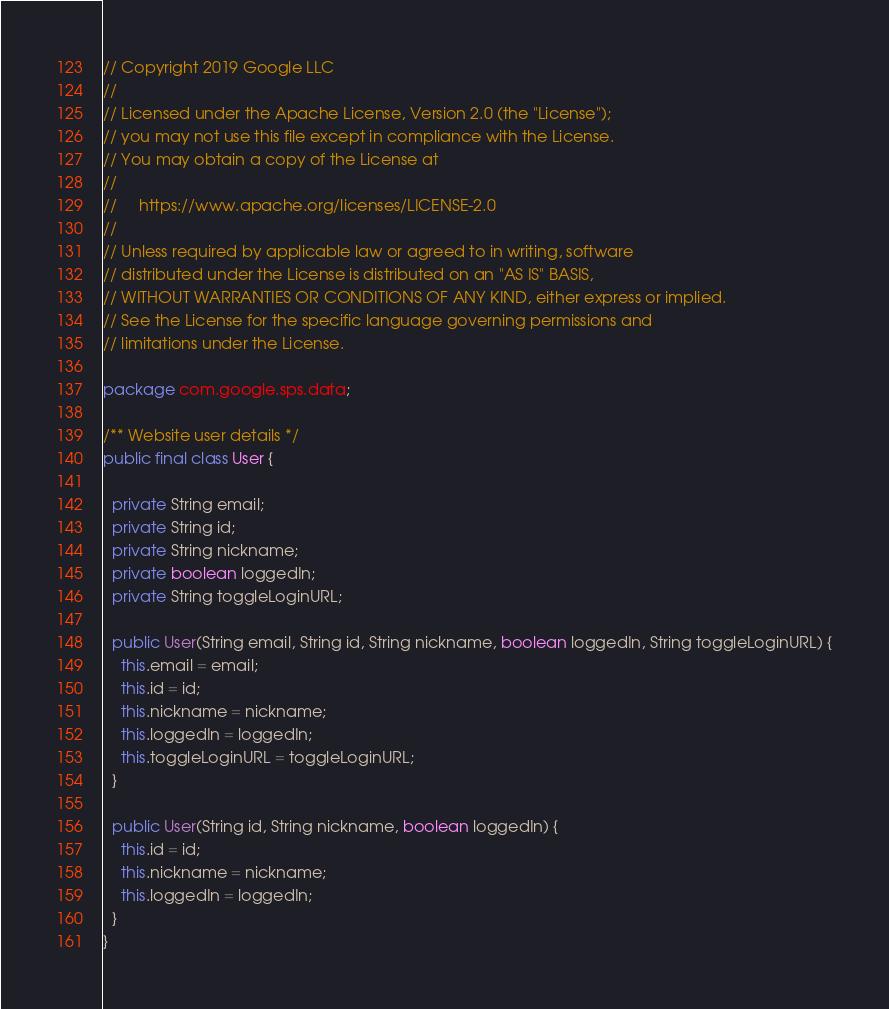Convert code to text. <code><loc_0><loc_0><loc_500><loc_500><_Java_>// Copyright 2019 Google LLC
//
// Licensed under the Apache License, Version 2.0 (the "License");
// you may not use this file except in compliance with the License.
// You may obtain a copy of the License at
//
//     https://www.apache.org/licenses/LICENSE-2.0
//
// Unless required by applicable law or agreed to in writing, software
// distributed under the License is distributed on an "AS IS" BASIS,
// WITHOUT WARRANTIES OR CONDITIONS OF ANY KIND, either express or implied.
// See the License for the specific language governing permissions and
// limitations under the License.

package com.google.sps.data;

/** Website user details */
public final class User {

  private String email;
  private String id;
  private String nickname;
  private boolean loggedIn;
  private String toggleLoginURL;

  public User(String email, String id, String nickname, boolean loggedIn, String toggleLoginURL) {
    this.email = email;
    this.id = id;
    this.nickname = nickname;
    this.loggedIn = loggedIn;
    this.toggleLoginURL = toggleLoginURL;
  }

  public User(String id, String nickname, boolean loggedIn) {
    this.id = id;
    this.nickname = nickname;
    this.loggedIn = loggedIn;
  }
}</code> 